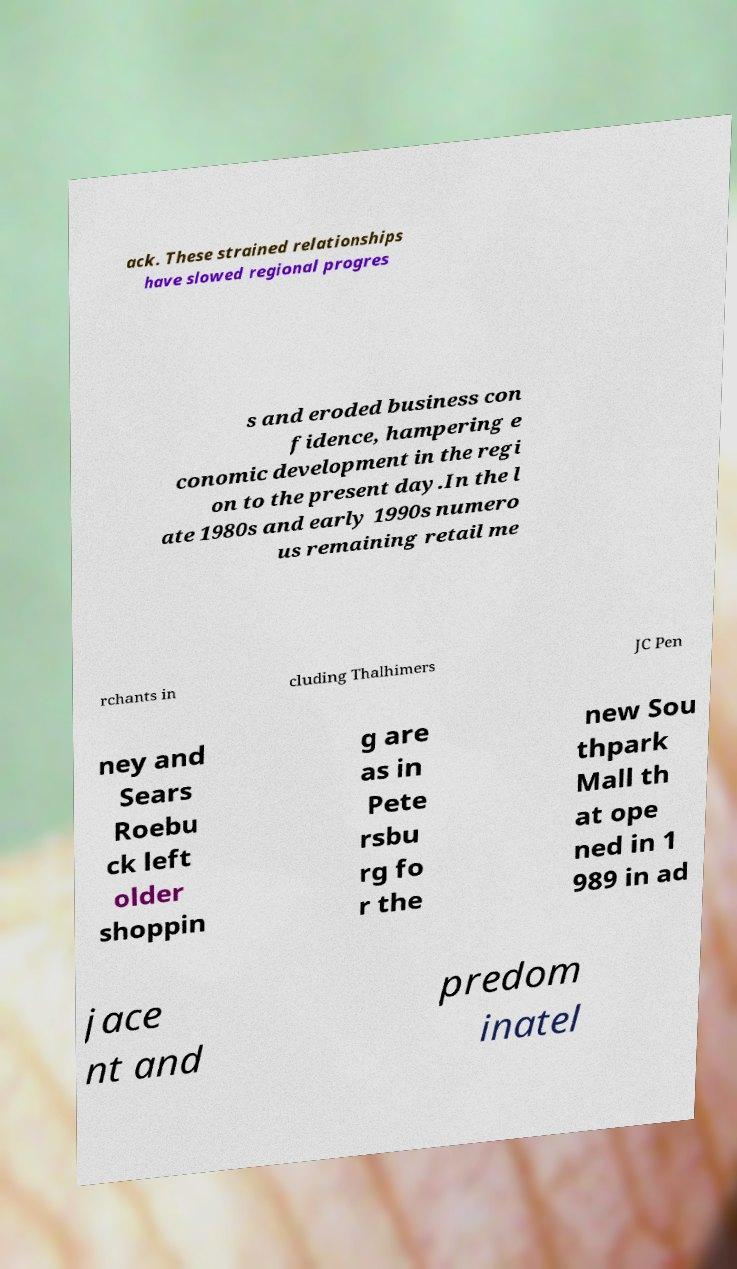Could you extract and type out the text from this image? ack. These strained relationships have slowed regional progres s and eroded business con fidence, hampering e conomic development in the regi on to the present day.In the l ate 1980s and early 1990s numero us remaining retail me rchants in cluding Thalhimers JC Pen ney and Sears Roebu ck left older shoppin g are as in Pete rsbu rg fo r the new Sou thpark Mall th at ope ned in 1 989 in ad jace nt and predom inatel 